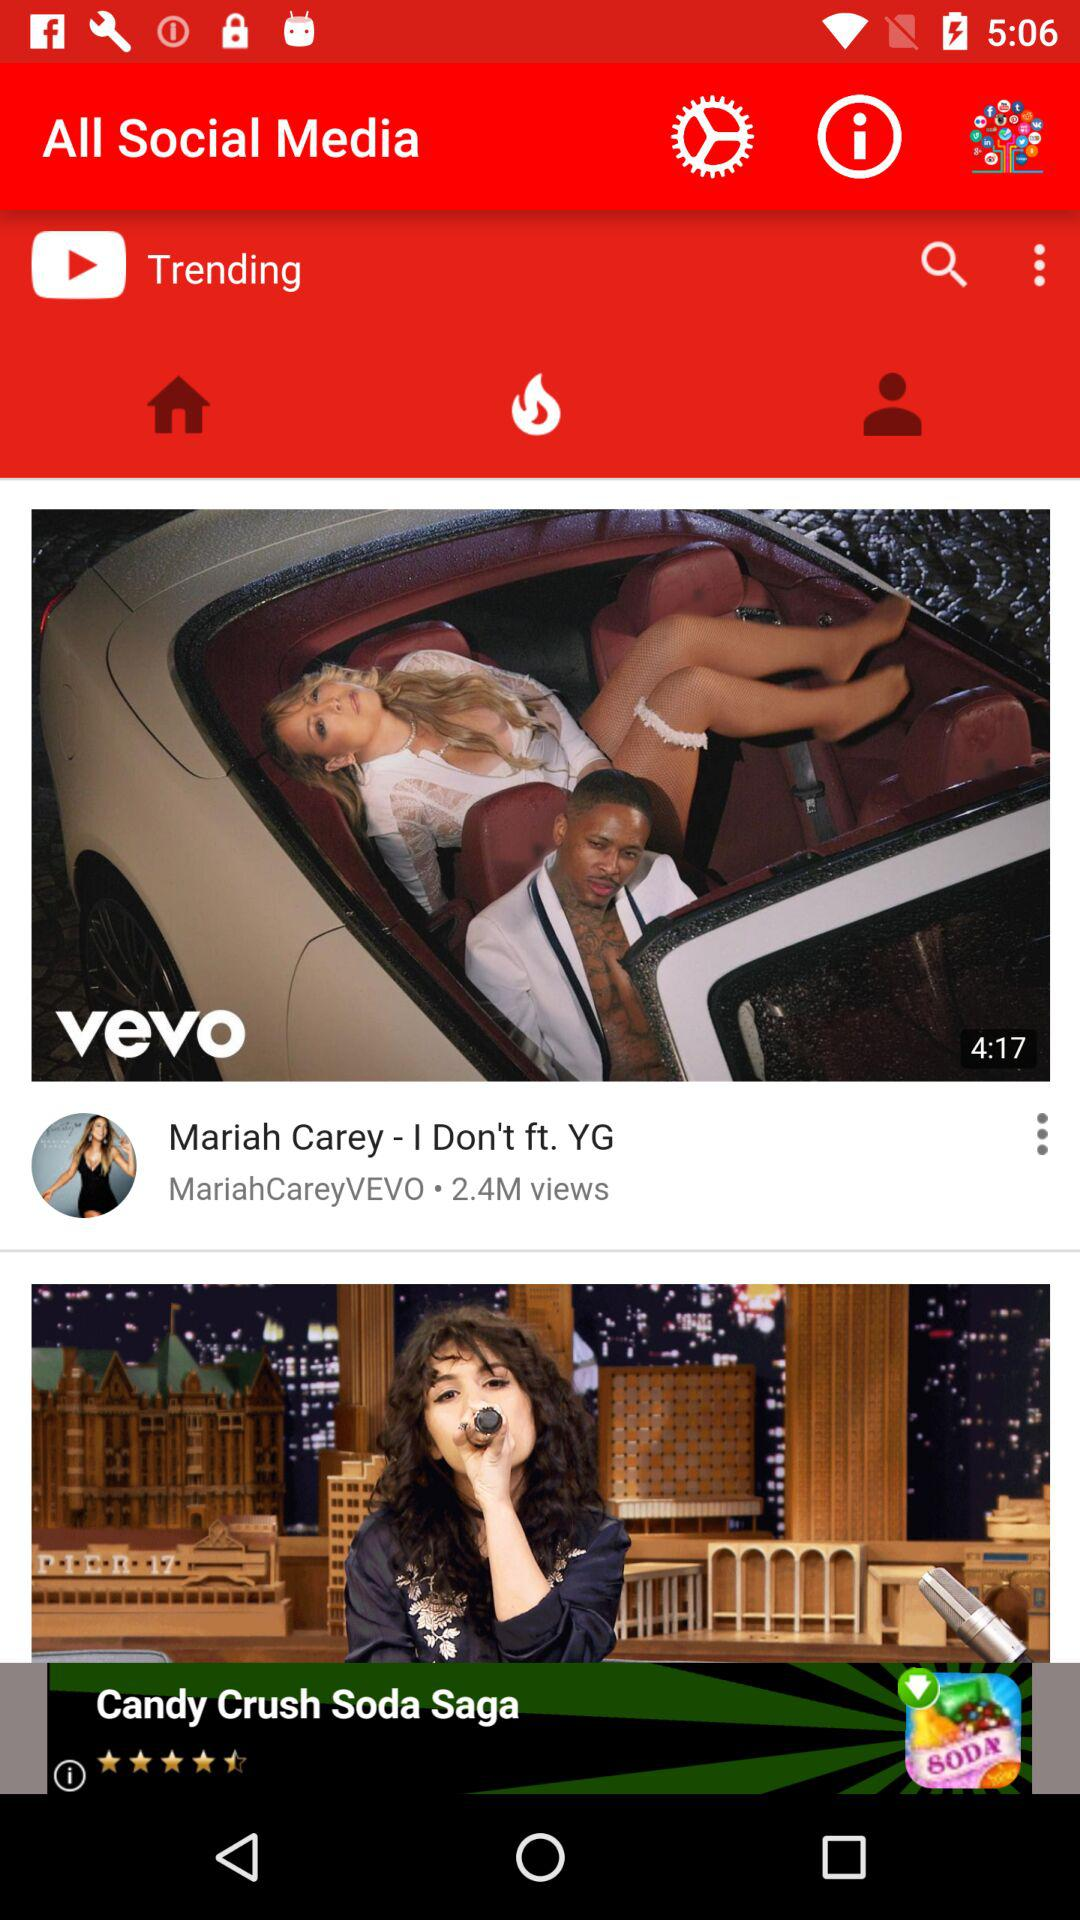What is the time duration of the video "I Don't ft. YG"? The duration of the video is 4 minutes and 17 seconds. 